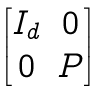<formula> <loc_0><loc_0><loc_500><loc_500>\begin{bmatrix} I _ { d } & 0 \\ 0 & P \end{bmatrix}</formula> 